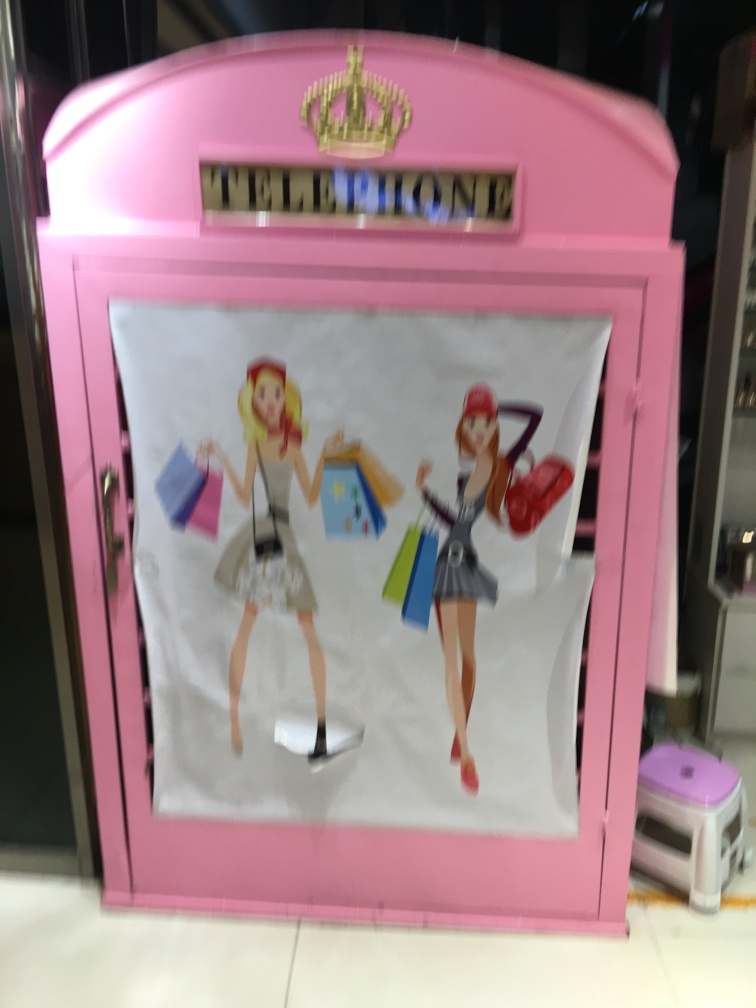Is the picture of average quality? The image is somewhat blurry and the framing is off-center, affecting its overall quality. Additionally, the aesthetics of the photo could be improved by adjusting the camera focus and composing the shot more carefully to capture the subject matter—which appears to be an ornately decorated pink telephone booth with two illustrated female characters on the front—more clearly. 